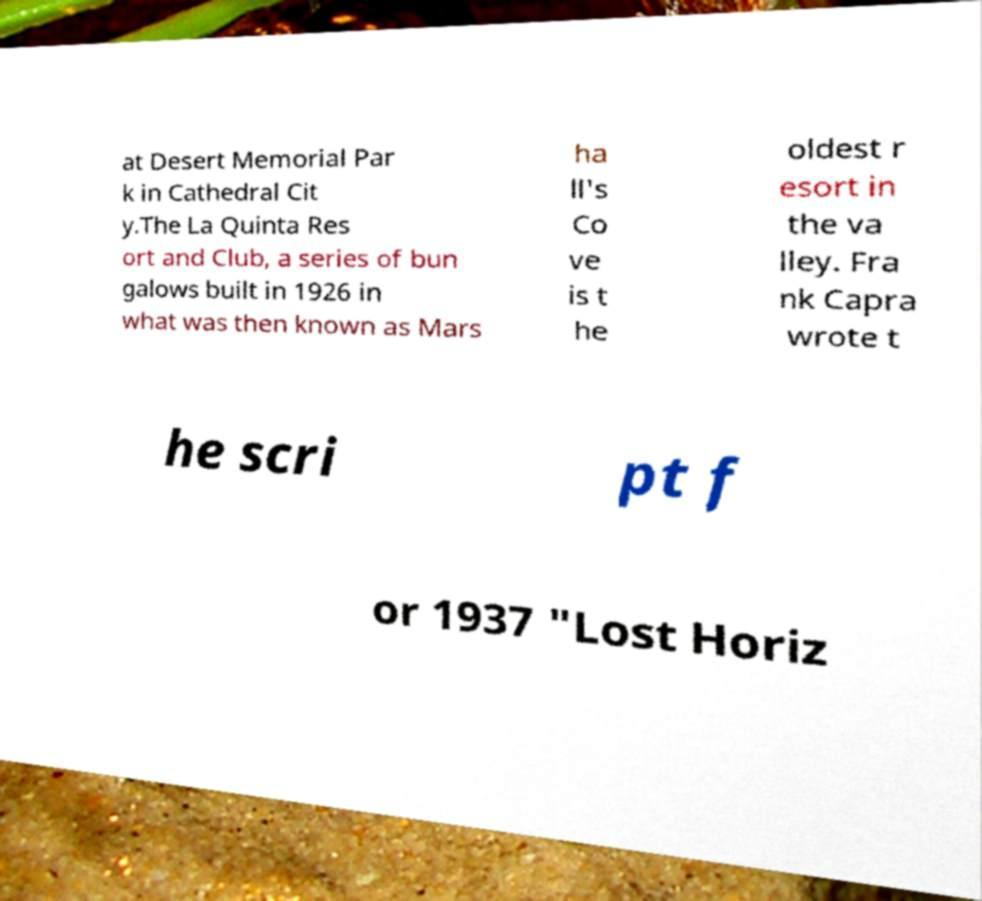There's text embedded in this image that I need extracted. Can you transcribe it verbatim? at Desert Memorial Par k in Cathedral Cit y.The La Quinta Res ort and Club, a series of bun galows built in 1926 in what was then known as Mars ha ll's Co ve is t he oldest r esort in the va lley. Fra nk Capra wrote t he scri pt f or 1937 "Lost Horiz 